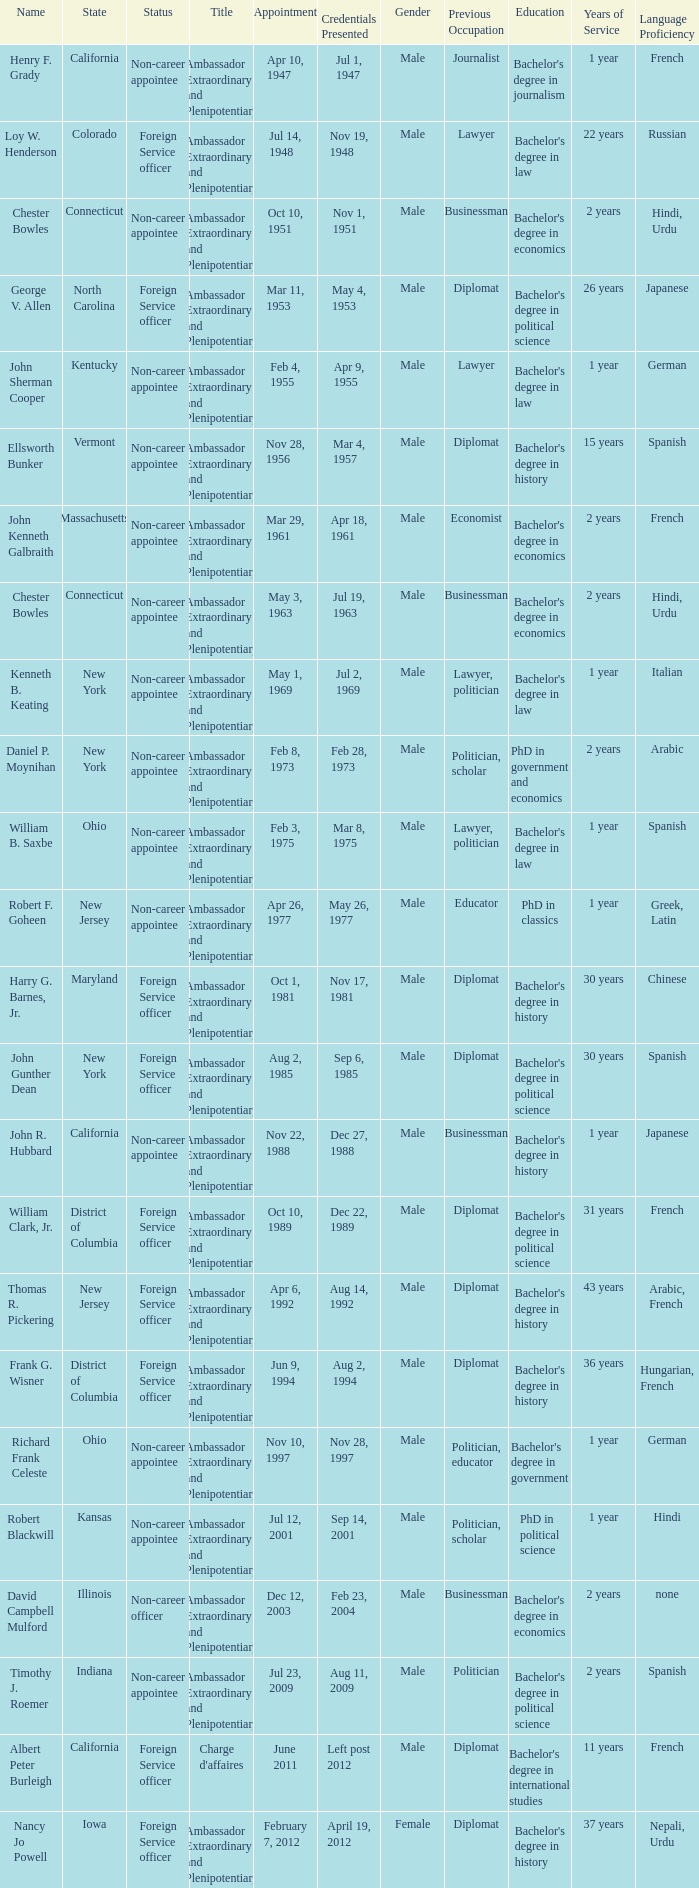What state has an appointment for jul 12, 2001? Kansas. 